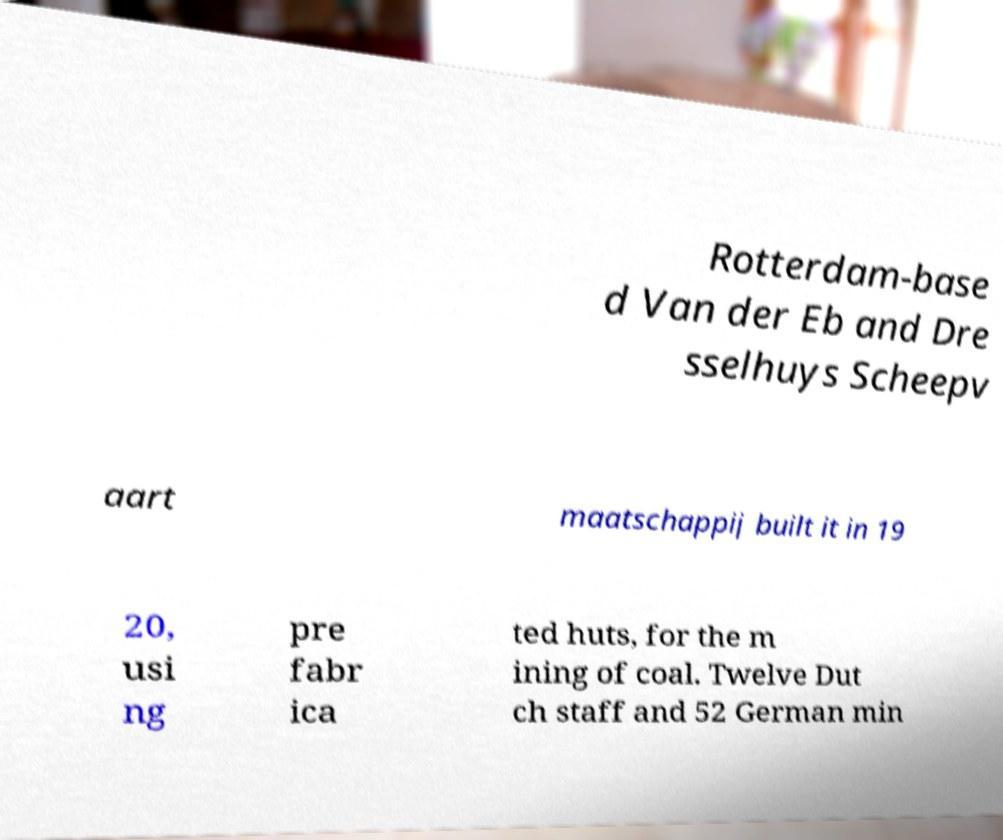Can you accurately transcribe the text from the provided image for me? Rotterdam-base d Van der Eb and Dre sselhuys Scheepv aart maatschappij built it in 19 20, usi ng pre fabr ica ted huts, for the m ining of coal. Twelve Dut ch staff and 52 German min 